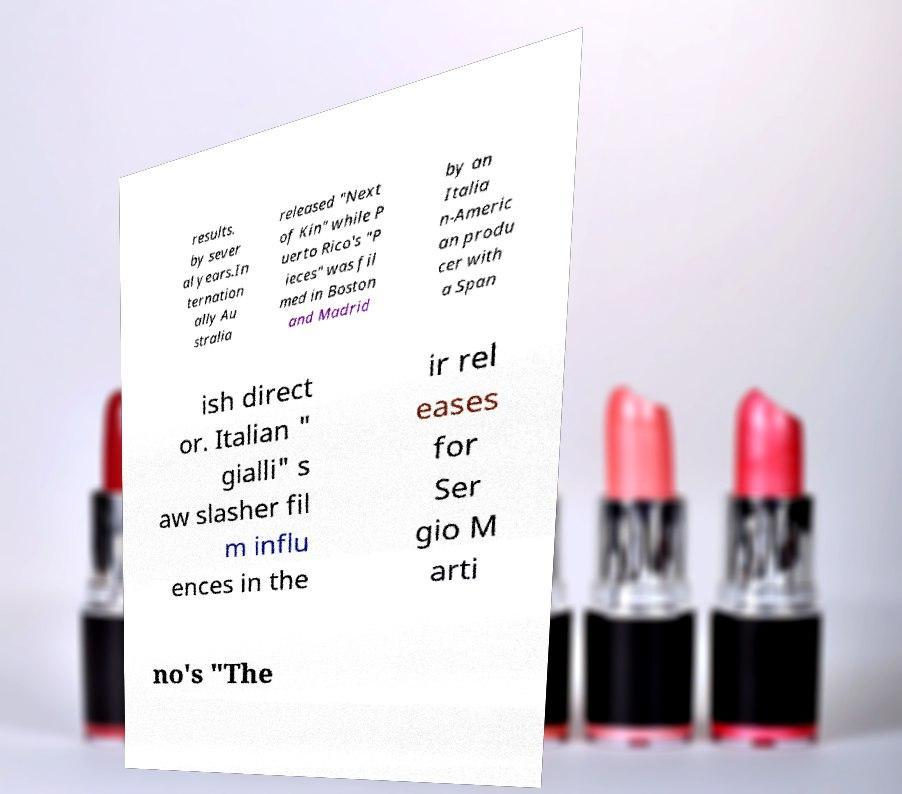There's text embedded in this image that I need extracted. Can you transcribe it verbatim? results. by sever al years.In ternation ally Au stralia released "Next of Kin" while P uerto Rico's "P ieces" was fil med in Boston and Madrid by an Italia n-Americ an produ cer with a Span ish direct or. Italian " gialli" s aw slasher fil m influ ences in the ir rel eases for Ser gio M arti no's "The 